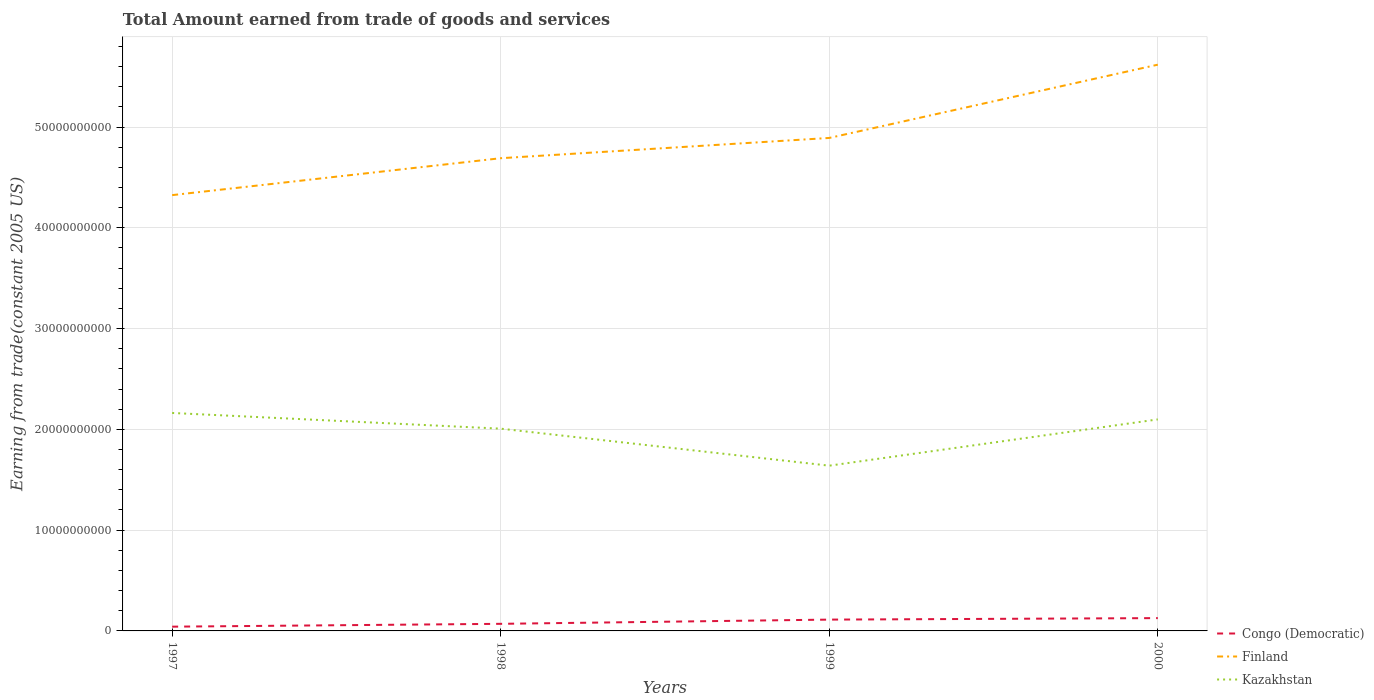How many different coloured lines are there?
Offer a very short reply. 3. Does the line corresponding to Finland intersect with the line corresponding to Congo (Democratic)?
Make the answer very short. No. Is the number of lines equal to the number of legend labels?
Your response must be concise. Yes. Across all years, what is the maximum total amount earned by trading goods and services in Kazakhstan?
Provide a short and direct response. 1.64e+1. In which year was the total amount earned by trading goods and services in Finland maximum?
Your answer should be compact. 1997. What is the total total amount earned by trading goods and services in Congo (Democratic) in the graph?
Ensure brevity in your answer.  -8.50e+08. What is the difference between the highest and the second highest total amount earned by trading goods and services in Congo (Democratic)?
Your answer should be compact. 8.50e+08. Are the values on the major ticks of Y-axis written in scientific E-notation?
Ensure brevity in your answer.  No. How are the legend labels stacked?
Your answer should be compact. Vertical. What is the title of the graph?
Provide a succinct answer. Total Amount earned from trade of goods and services. What is the label or title of the Y-axis?
Make the answer very short. Earning from trade(constant 2005 US). What is the Earning from trade(constant 2005 US) in Congo (Democratic) in 1997?
Provide a short and direct response. 4.22e+08. What is the Earning from trade(constant 2005 US) in Finland in 1997?
Offer a terse response. 4.32e+1. What is the Earning from trade(constant 2005 US) in Kazakhstan in 1997?
Make the answer very short. 2.16e+1. What is the Earning from trade(constant 2005 US) in Congo (Democratic) in 1998?
Offer a terse response. 7.04e+08. What is the Earning from trade(constant 2005 US) of Finland in 1998?
Keep it short and to the point. 4.69e+1. What is the Earning from trade(constant 2005 US) in Kazakhstan in 1998?
Provide a short and direct response. 2.01e+1. What is the Earning from trade(constant 2005 US) of Congo (Democratic) in 1999?
Keep it short and to the point. 1.12e+09. What is the Earning from trade(constant 2005 US) of Finland in 1999?
Provide a short and direct response. 4.89e+1. What is the Earning from trade(constant 2005 US) of Kazakhstan in 1999?
Give a very brief answer. 1.64e+1. What is the Earning from trade(constant 2005 US) of Congo (Democratic) in 2000?
Your response must be concise. 1.27e+09. What is the Earning from trade(constant 2005 US) in Finland in 2000?
Your response must be concise. 5.62e+1. What is the Earning from trade(constant 2005 US) of Kazakhstan in 2000?
Offer a terse response. 2.10e+1. Across all years, what is the maximum Earning from trade(constant 2005 US) in Congo (Democratic)?
Your response must be concise. 1.27e+09. Across all years, what is the maximum Earning from trade(constant 2005 US) in Finland?
Your response must be concise. 5.62e+1. Across all years, what is the maximum Earning from trade(constant 2005 US) in Kazakhstan?
Your response must be concise. 2.16e+1. Across all years, what is the minimum Earning from trade(constant 2005 US) of Congo (Democratic)?
Ensure brevity in your answer.  4.22e+08. Across all years, what is the minimum Earning from trade(constant 2005 US) in Finland?
Offer a terse response. 4.32e+1. Across all years, what is the minimum Earning from trade(constant 2005 US) of Kazakhstan?
Your answer should be compact. 1.64e+1. What is the total Earning from trade(constant 2005 US) of Congo (Democratic) in the graph?
Provide a succinct answer. 3.52e+09. What is the total Earning from trade(constant 2005 US) of Finland in the graph?
Ensure brevity in your answer.  1.95e+11. What is the total Earning from trade(constant 2005 US) of Kazakhstan in the graph?
Offer a terse response. 7.91e+1. What is the difference between the Earning from trade(constant 2005 US) in Congo (Democratic) in 1997 and that in 1998?
Your answer should be compact. -2.82e+08. What is the difference between the Earning from trade(constant 2005 US) of Finland in 1997 and that in 1998?
Your answer should be very brief. -3.66e+09. What is the difference between the Earning from trade(constant 2005 US) in Kazakhstan in 1997 and that in 1998?
Offer a terse response. 1.56e+09. What is the difference between the Earning from trade(constant 2005 US) in Congo (Democratic) in 1997 and that in 1999?
Offer a very short reply. -7.01e+08. What is the difference between the Earning from trade(constant 2005 US) of Finland in 1997 and that in 1999?
Provide a short and direct response. -5.67e+09. What is the difference between the Earning from trade(constant 2005 US) in Kazakhstan in 1997 and that in 1999?
Offer a very short reply. 5.23e+09. What is the difference between the Earning from trade(constant 2005 US) of Congo (Democratic) in 1997 and that in 2000?
Your answer should be compact. -8.50e+08. What is the difference between the Earning from trade(constant 2005 US) in Finland in 1997 and that in 2000?
Make the answer very short. -1.29e+1. What is the difference between the Earning from trade(constant 2005 US) of Kazakhstan in 1997 and that in 2000?
Your answer should be very brief. 6.39e+08. What is the difference between the Earning from trade(constant 2005 US) of Congo (Democratic) in 1998 and that in 1999?
Provide a short and direct response. -4.18e+08. What is the difference between the Earning from trade(constant 2005 US) in Finland in 1998 and that in 1999?
Ensure brevity in your answer.  -2.01e+09. What is the difference between the Earning from trade(constant 2005 US) of Kazakhstan in 1998 and that in 1999?
Make the answer very short. 3.67e+09. What is the difference between the Earning from trade(constant 2005 US) of Congo (Democratic) in 1998 and that in 2000?
Your answer should be very brief. -5.68e+08. What is the difference between the Earning from trade(constant 2005 US) of Finland in 1998 and that in 2000?
Keep it short and to the point. -9.28e+09. What is the difference between the Earning from trade(constant 2005 US) in Kazakhstan in 1998 and that in 2000?
Provide a succinct answer. -9.18e+08. What is the difference between the Earning from trade(constant 2005 US) in Congo (Democratic) in 1999 and that in 2000?
Make the answer very short. -1.49e+08. What is the difference between the Earning from trade(constant 2005 US) of Finland in 1999 and that in 2000?
Your answer should be very brief. -7.27e+09. What is the difference between the Earning from trade(constant 2005 US) in Kazakhstan in 1999 and that in 2000?
Give a very brief answer. -4.59e+09. What is the difference between the Earning from trade(constant 2005 US) in Congo (Democratic) in 1997 and the Earning from trade(constant 2005 US) in Finland in 1998?
Your answer should be compact. -4.65e+1. What is the difference between the Earning from trade(constant 2005 US) in Congo (Democratic) in 1997 and the Earning from trade(constant 2005 US) in Kazakhstan in 1998?
Provide a succinct answer. -1.96e+1. What is the difference between the Earning from trade(constant 2005 US) of Finland in 1997 and the Earning from trade(constant 2005 US) of Kazakhstan in 1998?
Your answer should be very brief. 2.32e+1. What is the difference between the Earning from trade(constant 2005 US) of Congo (Democratic) in 1997 and the Earning from trade(constant 2005 US) of Finland in 1999?
Make the answer very short. -4.85e+1. What is the difference between the Earning from trade(constant 2005 US) of Congo (Democratic) in 1997 and the Earning from trade(constant 2005 US) of Kazakhstan in 1999?
Make the answer very short. -1.60e+1. What is the difference between the Earning from trade(constant 2005 US) of Finland in 1997 and the Earning from trade(constant 2005 US) of Kazakhstan in 1999?
Make the answer very short. 2.68e+1. What is the difference between the Earning from trade(constant 2005 US) of Congo (Democratic) in 1997 and the Earning from trade(constant 2005 US) of Finland in 2000?
Keep it short and to the point. -5.58e+1. What is the difference between the Earning from trade(constant 2005 US) of Congo (Democratic) in 1997 and the Earning from trade(constant 2005 US) of Kazakhstan in 2000?
Ensure brevity in your answer.  -2.06e+1. What is the difference between the Earning from trade(constant 2005 US) in Finland in 1997 and the Earning from trade(constant 2005 US) in Kazakhstan in 2000?
Your answer should be very brief. 2.23e+1. What is the difference between the Earning from trade(constant 2005 US) in Congo (Democratic) in 1998 and the Earning from trade(constant 2005 US) in Finland in 1999?
Your answer should be compact. -4.82e+1. What is the difference between the Earning from trade(constant 2005 US) of Congo (Democratic) in 1998 and the Earning from trade(constant 2005 US) of Kazakhstan in 1999?
Keep it short and to the point. -1.57e+1. What is the difference between the Earning from trade(constant 2005 US) in Finland in 1998 and the Earning from trade(constant 2005 US) in Kazakhstan in 1999?
Make the answer very short. 3.05e+1. What is the difference between the Earning from trade(constant 2005 US) of Congo (Democratic) in 1998 and the Earning from trade(constant 2005 US) of Finland in 2000?
Offer a very short reply. -5.55e+1. What is the difference between the Earning from trade(constant 2005 US) in Congo (Democratic) in 1998 and the Earning from trade(constant 2005 US) in Kazakhstan in 2000?
Provide a short and direct response. -2.03e+1. What is the difference between the Earning from trade(constant 2005 US) in Finland in 1998 and the Earning from trade(constant 2005 US) in Kazakhstan in 2000?
Offer a terse response. 2.59e+1. What is the difference between the Earning from trade(constant 2005 US) of Congo (Democratic) in 1999 and the Earning from trade(constant 2005 US) of Finland in 2000?
Make the answer very short. -5.51e+1. What is the difference between the Earning from trade(constant 2005 US) in Congo (Democratic) in 1999 and the Earning from trade(constant 2005 US) in Kazakhstan in 2000?
Your answer should be very brief. -1.99e+1. What is the difference between the Earning from trade(constant 2005 US) of Finland in 1999 and the Earning from trade(constant 2005 US) of Kazakhstan in 2000?
Make the answer very short. 2.79e+1. What is the average Earning from trade(constant 2005 US) in Congo (Democratic) per year?
Keep it short and to the point. 8.80e+08. What is the average Earning from trade(constant 2005 US) in Finland per year?
Your answer should be compact. 4.88e+1. What is the average Earning from trade(constant 2005 US) of Kazakhstan per year?
Make the answer very short. 1.98e+1. In the year 1997, what is the difference between the Earning from trade(constant 2005 US) in Congo (Democratic) and Earning from trade(constant 2005 US) in Finland?
Your response must be concise. -4.28e+1. In the year 1997, what is the difference between the Earning from trade(constant 2005 US) of Congo (Democratic) and Earning from trade(constant 2005 US) of Kazakhstan?
Ensure brevity in your answer.  -2.12e+1. In the year 1997, what is the difference between the Earning from trade(constant 2005 US) in Finland and Earning from trade(constant 2005 US) in Kazakhstan?
Your response must be concise. 2.16e+1. In the year 1998, what is the difference between the Earning from trade(constant 2005 US) in Congo (Democratic) and Earning from trade(constant 2005 US) in Finland?
Your answer should be compact. -4.62e+1. In the year 1998, what is the difference between the Earning from trade(constant 2005 US) of Congo (Democratic) and Earning from trade(constant 2005 US) of Kazakhstan?
Your answer should be compact. -1.94e+1. In the year 1998, what is the difference between the Earning from trade(constant 2005 US) of Finland and Earning from trade(constant 2005 US) of Kazakhstan?
Make the answer very short. 2.68e+1. In the year 1999, what is the difference between the Earning from trade(constant 2005 US) in Congo (Democratic) and Earning from trade(constant 2005 US) in Finland?
Offer a terse response. -4.78e+1. In the year 1999, what is the difference between the Earning from trade(constant 2005 US) of Congo (Democratic) and Earning from trade(constant 2005 US) of Kazakhstan?
Keep it short and to the point. -1.53e+1. In the year 1999, what is the difference between the Earning from trade(constant 2005 US) of Finland and Earning from trade(constant 2005 US) of Kazakhstan?
Keep it short and to the point. 3.25e+1. In the year 2000, what is the difference between the Earning from trade(constant 2005 US) of Congo (Democratic) and Earning from trade(constant 2005 US) of Finland?
Provide a short and direct response. -5.49e+1. In the year 2000, what is the difference between the Earning from trade(constant 2005 US) of Congo (Democratic) and Earning from trade(constant 2005 US) of Kazakhstan?
Offer a very short reply. -1.97e+1. In the year 2000, what is the difference between the Earning from trade(constant 2005 US) in Finland and Earning from trade(constant 2005 US) in Kazakhstan?
Give a very brief answer. 3.52e+1. What is the ratio of the Earning from trade(constant 2005 US) of Congo (Democratic) in 1997 to that in 1998?
Offer a terse response. 0.6. What is the ratio of the Earning from trade(constant 2005 US) of Finland in 1997 to that in 1998?
Ensure brevity in your answer.  0.92. What is the ratio of the Earning from trade(constant 2005 US) of Kazakhstan in 1997 to that in 1998?
Your answer should be compact. 1.08. What is the ratio of the Earning from trade(constant 2005 US) of Congo (Democratic) in 1997 to that in 1999?
Your response must be concise. 0.38. What is the ratio of the Earning from trade(constant 2005 US) of Finland in 1997 to that in 1999?
Ensure brevity in your answer.  0.88. What is the ratio of the Earning from trade(constant 2005 US) of Kazakhstan in 1997 to that in 1999?
Your response must be concise. 1.32. What is the ratio of the Earning from trade(constant 2005 US) in Congo (Democratic) in 1997 to that in 2000?
Make the answer very short. 0.33. What is the ratio of the Earning from trade(constant 2005 US) in Finland in 1997 to that in 2000?
Offer a very short reply. 0.77. What is the ratio of the Earning from trade(constant 2005 US) in Kazakhstan in 1997 to that in 2000?
Your answer should be very brief. 1.03. What is the ratio of the Earning from trade(constant 2005 US) in Congo (Democratic) in 1998 to that in 1999?
Offer a very short reply. 0.63. What is the ratio of the Earning from trade(constant 2005 US) in Finland in 1998 to that in 1999?
Offer a terse response. 0.96. What is the ratio of the Earning from trade(constant 2005 US) of Kazakhstan in 1998 to that in 1999?
Provide a short and direct response. 1.22. What is the ratio of the Earning from trade(constant 2005 US) of Congo (Democratic) in 1998 to that in 2000?
Keep it short and to the point. 0.55. What is the ratio of the Earning from trade(constant 2005 US) of Finland in 1998 to that in 2000?
Your answer should be very brief. 0.83. What is the ratio of the Earning from trade(constant 2005 US) in Kazakhstan in 1998 to that in 2000?
Offer a terse response. 0.96. What is the ratio of the Earning from trade(constant 2005 US) of Congo (Democratic) in 1999 to that in 2000?
Provide a short and direct response. 0.88. What is the ratio of the Earning from trade(constant 2005 US) in Finland in 1999 to that in 2000?
Your answer should be very brief. 0.87. What is the ratio of the Earning from trade(constant 2005 US) of Kazakhstan in 1999 to that in 2000?
Give a very brief answer. 0.78. What is the difference between the highest and the second highest Earning from trade(constant 2005 US) in Congo (Democratic)?
Provide a short and direct response. 1.49e+08. What is the difference between the highest and the second highest Earning from trade(constant 2005 US) of Finland?
Your answer should be compact. 7.27e+09. What is the difference between the highest and the second highest Earning from trade(constant 2005 US) in Kazakhstan?
Provide a short and direct response. 6.39e+08. What is the difference between the highest and the lowest Earning from trade(constant 2005 US) in Congo (Democratic)?
Keep it short and to the point. 8.50e+08. What is the difference between the highest and the lowest Earning from trade(constant 2005 US) of Finland?
Keep it short and to the point. 1.29e+1. What is the difference between the highest and the lowest Earning from trade(constant 2005 US) of Kazakhstan?
Keep it short and to the point. 5.23e+09. 